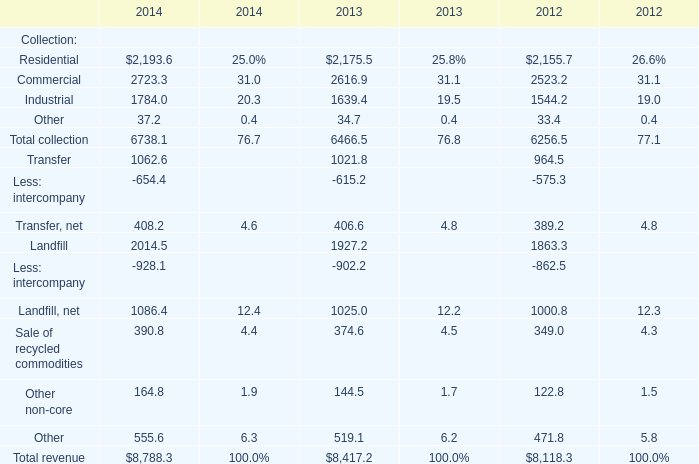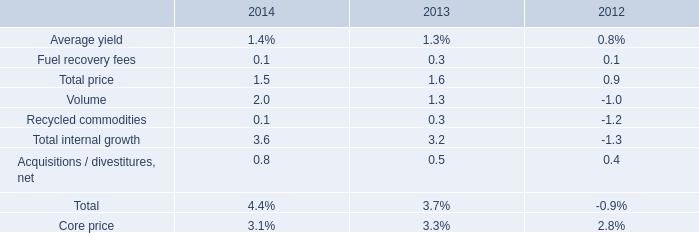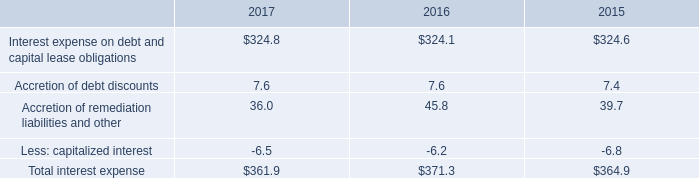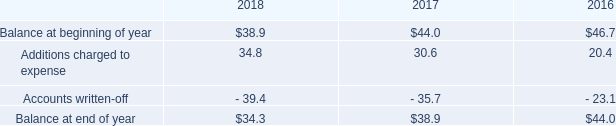as of december 31 , 2018 what was the percentage decline in the allowance for doubtful accounts 
Computations: ((34.3 - 38.9) / 38.9)
Answer: -0.11825. 